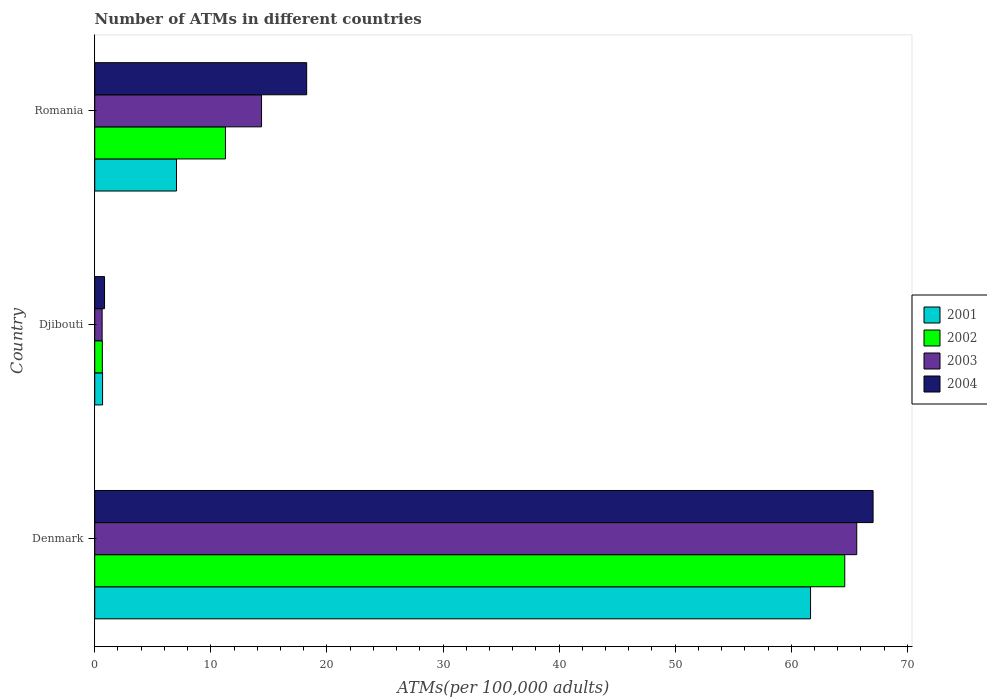How many groups of bars are there?
Keep it short and to the point. 3. Are the number of bars per tick equal to the number of legend labels?
Offer a terse response. Yes. Are the number of bars on each tick of the Y-axis equal?
Make the answer very short. Yes. How many bars are there on the 1st tick from the top?
Give a very brief answer. 4. How many bars are there on the 3rd tick from the bottom?
Give a very brief answer. 4. In how many cases, is the number of bars for a given country not equal to the number of legend labels?
Your answer should be very brief. 0. What is the number of ATMs in 2003 in Djibouti?
Keep it short and to the point. 0.64. Across all countries, what is the maximum number of ATMs in 2002?
Provide a succinct answer. 64.61. Across all countries, what is the minimum number of ATMs in 2001?
Keep it short and to the point. 0.68. In which country was the number of ATMs in 2002 minimum?
Your answer should be very brief. Djibouti. What is the total number of ATMs in 2001 in the graph?
Make the answer very short. 69.38. What is the difference between the number of ATMs in 2003 in Djibouti and that in Romania?
Your answer should be compact. -13.73. What is the difference between the number of ATMs in 2001 in Romania and the number of ATMs in 2002 in Djibouti?
Offer a terse response. 6.39. What is the average number of ATMs in 2002 per country?
Provide a short and direct response. 25.51. What is the difference between the number of ATMs in 2001 and number of ATMs in 2003 in Djibouti?
Offer a very short reply. 0.04. What is the ratio of the number of ATMs in 2003 in Denmark to that in Romania?
Provide a short and direct response. 4.57. What is the difference between the highest and the second highest number of ATMs in 2004?
Make the answer very short. 48.79. What is the difference between the highest and the lowest number of ATMs in 2004?
Your answer should be compact. 66.2. In how many countries, is the number of ATMs in 2003 greater than the average number of ATMs in 2003 taken over all countries?
Offer a very short reply. 1. Is the sum of the number of ATMs in 2003 in Denmark and Djibouti greater than the maximum number of ATMs in 2001 across all countries?
Offer a very short reply. Yes. Is it the case that in every country, the sum of the number of ATMs in 2002 and number of ATMs in 2001 is greater than the sum of number of ATMs in 2003 and number of ATMs in 2004?
Keep it short and to the point. No. What does the 4th bar from the bottom in Denmark represents?
Your answer should be compact. 2004. Are all the bars in the graph horizontal?
Your answer should be very brief. Yes. How many countries are there in the graph?
Provide a succinct answer. 3. What is the difference between two consecutive major ticks on the X-axis?
Ensure brevity in your answer.  10. Does the graph contain any zero values?
Provide a short and direct response. No. Where does the legend appear in the graph?
Offer a very short reply. Center right. What is the title of the graph?
Your answer should be compact. Number of ATMs in different countries. What is the label or title of the X-axis?
Keep it short and to the point. ATMs(per 100,0 adults). What is the label or title of the Y-axis?
Ensure brevity in your answer.  Country. What is the ATMs(per 100,000 adults) in 2001 in Denmark?
Ensure brevity in your answer.  61.66. What is the ATMs(per 100,000 adults) in 2002 in Denmark?
Give a very brief answer. 64.61. What is the ATMs(per 100,000 adults) of 2003 in Denmark?
Your answer should be very brief. 65.64. What is the ATMs(per 100,000 adults) of 2004 in Denmark?
Keep it short and to the point. 67.04. What is the ATMs(per 100,000 adults) of 2001 in Djibouti?
Give a very brief answer. 0.68. What is the ATMs(per 100,000 adults) in 2002 in Djibouti?
Offer a terse response. 0.66. What is the ATMs(per 100,000 adults) in 2003 in Djibouti?
Offer a very short reply. 0.64. What is the ATMs(per 100,000 adults) of 2004 in Djibouti?
Provide a short and direct response. 0.84. What is the ATMs(per 100,000 adults) of 2001 in Romania?
Provide a succinct answer. 7.04. What is the ATMs(per 100,000 adults) of 2002 in Romania?
Your answer should be compact. 11.26. What is the ATMs(per 100,000 adults) in 2003 in Romania?
Offer a terse response. 14.37. What is the ATMs(per 100,000 adults) of 2004 in Romania?
Your answer should be compact. 18.26. Across all countries, what is the maximum ATMs(per 100,000 adults) in 2001?
Offer a terse response. 61.66. Across all countries, what is the maximum ATMs(per 100,000 adults) in 2002?
Offer a terse response. 64.61. Across all countries, what is the maximum ATMs(per 100,000 adults) of 2003?
Offer a terse response. 65.64. Across all countries, what is the maximum ATMs(per 100,000 adults) in 2004?
Offer a very short reply. 67.04. Across all countries, what is the minimum ATMs(per 100,000 adults) in 2001?
Offer a terse response. 0.68. Across all countries, what is the minimum ATMs(per 100,000 adults) of 2002?
Your answer should be very brief. 0.66. Across all countries, what is the minimum ATMs(per 100,000 adults) of 2003?
Your response must be concise. 0.64. Across all countries, what is the minimum ATMs(per 100,000 adults) of 2004?
Offer a terse response. 0.84. What is the total ATMs(per 100,000 adults) of 2001 in the graph?
Your response must be concise. 69.38. What is the total ATMs(per 100,000 adults) in 2002 in the graph?
Your answer should be very brief. 76.52. What is the total ATMs(per 100,000 adults) in 2003 in the graph?
Your answer should be compact. 80.65. What is the total ATMs(per 100,000 adults) in 2004 in the graph?
Provide a short and direct response. 86.14. What is the difference between the ATMs(per 100,000 adults) of 2001 in Denmark and that in Djibouti?
Provide a succinct answer. 60.98. What is the difference between the ATMs(per 100,000 adults) of 2002 in Denmark and that in Djibouti?
Offer a very short reply. 63.95. What is the difference between the ATMs(per 100,000 adults) in 2003 in Denmark and that in Djibouti?
Provide a succinct answer. 65. What is the difference between the ATMs(per 100,000 adults) of 2004 in Denmark and that in Djibouti?
Make the answer very short. 66.2. What is the difference between the ATMs(per 100,000 adults) of 2001 in Denmark and that in Romania?
Give a very brief answer. 54.61. What is the difference between the ATMs(per 100,000 adults) of 2002 in Denmark and that in Romania?
Provide a succinct answer. 53.35. What is the difference between the ATMs(per 100,000 adults) in 2003 in Denmark and that in Romania?
Keep it short and to the point. 51.27. What is the difference between the ATMs(per 100,000 adults) of 2004 in Denmark and that in Romania?
Offer a terse response. 48.79. What is the difference between the ATMs(per 100,000 adults) of 2001 in Djibouti and that in Romania?
Provide a short and direct response. -6.37. What is the difference between the ATMs(per 100,000 adults) of 2002 in Djibouti and that in Romania?
Provide a succinct answer. -10.6. What is the difference between the ATMs(per 100,000 adults) in 2003 in Djibouti and that in Romania?
Provide a succinct answer. -13.73. What is the difference between the ATMs(per 100,000 adults) of 2004 in Djibouti and that in Romania?
Your answer should be very brief. -17.41. What is the difference between the ATMs(per 100,000 adults) in 2001 in Denmark and the ATMs(per 100,000 adults) in 2002 in Djibouti?
Your answer should be very brief. 61. What is the difference between the ATMs(per 100,000 adults) in 2001 in Denmark and the ATMs(per 100,000 adults) in 2003 in Djibouti?
Provide a succinct answer. 61.02. What is the difference between the ATMs(per 100,000 adults) of 2001 in Denmark and the ATMs(per 100,000 adults) of 2004 in Djibouti?
Provide a short and direct response. 60.81. What is the difference between the ATMs(per 100,000 adults) of 2002 in Denmark and the ATMs(per 100,000 adults) of 2003 in Djibouti?
Offer a terse response. 63.97. What is the difference between the ATMs(per 100,000 adults) of 2002 in Denmark and the ATMs(per 100,000 adults) of 2004 in Djibouti?
Your answer should be compact. 63.76. What is the difference between the ATMs(per 100,000 adults) in 2003 in Denmark and the ATMs(per 100,000 adults) in 2004 in Djibouti?
Ensure brevity in your answer.  64.79. What is the difference between the ATMs(per 100,000 adults) in 2001 in Denmark and the ATMs(per 100,000 adults) in 2002 in Romania?
Your response must be concise. 50.4. What is the difference between the ATMs(per 100,000 adults) in 2001 in Denmark and the ATMs(per 100,000 adults) in 2003 in Romania?
Ensure brevity in your answer.  47.29. What is the difference between the ATMs(per 100,000 adults) in 2001 in Denmark and the ATMs(per 100,000 adults) in 2004 in Romania?
Offer a very short reply. 43.4. What is the difference between the ATMs(per 100,000 adults) of 2002 in Denmark and the ATMs(per 100,000 adults) of 2003 in Romania?
Provide a succinct answer. 50.24. What is the difference between the ATMs(per 100,000 adults) of 2002 in Denmark and the ATMs(per 100,000 adults) of 2004 in Romania?
Give a very brief answer. 46.35. What is the difference between the ATMs(per 100,000 adults) in 2003 in Denmark and the ATMs(per 100,000 adults) in 2004 in Romania?
Provide a short and direct response. 47.38. What is the difference between the ATMs(per 100,000 adults) of 2001 in Djibouti and the ATMs(per 100,000 adults) of 2002 in Romania?
Offer a very short reply. -10.58. What is the difference between the ATMs(per 100,000 adults) of 2001 in Djibouti and the ATMs(per 100,000 adults) of 2003 in Romania?
Provide a short and direct response. -13.69. What is the difference between the ATMs(per 100,000 adults) of 2001 in Djibouti and the ATMs(per 100,000 adults) of 2004 in Romania?
Provide a short and direct response. -17.58. What is the difference between the ATMs(per 100,000 adults) of 2002 in Djibouti and the ATMs(per 100,000 adults) of 2003 in Romania?
Your answer should be compact. -13.71. What is the difference between the ATMs(per 100,000 adults) of 2002 in Djibouti and the ATMs(per 100,000 adults) of 2004 in Romania?
Your answer should be very brief. -17.6. What is the difference between the ATMs(per 100,000 adults) of 2003 in Djibouti and the ATMs(per 100,000 adults) of 2004 in Romania?
Give a very brief answer. -17.62. What is the average ATMs(per 100,000 adults) in 2001 per country?
Give a very brief answer. 23.13. What is the average ATMs(per 100,000 adults) of 2002 per country?
Your answer should be very brief. 25.51. What is the average ATMs(per 100,000 adults) of 2003 per country?
Your answer should be very brief. 26.88. What is the average ATMs(per 100,000 adults) of 2004 per country?
Your answer should be very brief. 28.71. What is the difference between the ATMs(per 100,000 adults) of 2001 and ATMs(per 100,000 adults) of 2002 in Denmark?
Make the answer very short. -2.95. What is the difference between the ATMs(per 100,000 adults) of 2001 and ATMs(per 100,000 adults) of 2003 in Denmark?
Offer a very short reply. -3.98. What is the difference between the ATMs(per 100,000 adults) in 2001 and ATMs(per 100,000 adults) in 2004 in Denmark?
Give a very brief answer. -5.39. What is the difference between the ATMs(per 100,000 adults) in 2002 and ATMs(per 100,000 adults) in 2003 in Denmark?
Provide a succinct answer. -1.03. What is the difference between the ATMs(per 100,000 adults) in 2002 and ATMs(per 100,000 adults) in 2004 in Denmark?
Ensure brevity in your answer.  -2.44. What is the difference between the ATMs(per 100,000 adults) in 2003 and ATMs(per 100,000 adults) in 2004 in Denmark?
Your answer should be very brief. -1.41. What is the difference between the ATMs(per 100,000 adults) in 2001 and ATMs(per 100,000 adults) in 2002 in Djibouti?
Ensure brevity in your answer.  0.02. What is the difference between the ATMs(per 100,000 adults) in 2001 and ATMs(per 100,000 adults) in 2003 in Djibouti?
Make the answer very short. 0.04. What is the difference between the ATMs(per 100,000 adults) in 2001 and ATMs(per 100,000 adults) in 2004 in Djibouti?
Your answer should be compact. -0.17. What is the difference between the ATMs(per 100,000 adults) in 2002 and ATMs(per 100,000 adults) in 2003 in Djibouti?
Offer a very short reply. 0.02. What is the difference between the ATMs(per 100,000 adults) in 2002 and ATMs(per 100,000 adults) in 2004 in Djibouti?
Ensure brevity in your answer.  -0.19. What is the difference between the ATMs(per 100,000 adults) of 2003 and ATMs(per 100,000 adults) of 2004 in Djibouti?
Make the answer very short. -0.21. What is the difference between the ATMs(per 100,000 adults) of 2001 and ATMs(per 100,000 adults) of 2002 in Romania?
Provide a short and direct response. -4.21. What is the difference between the ATMs(per 100,000 adults) of 2001 and ATMs(per 100,000 adults) of 2003 in Romania?
Your answer should be compact. -7.32. What is the difference between the ATMs(per 100,000 adults) in 2001 and ATMs(per 100,000 adults) in 2004 in Romania?
Your response must be concise. -11.21. What is the difference between the ATMs(per 100,000 adults) in 2002 and ATMs(per 100,000 adults) in 2003 in Romania?
Your answer should be very brief. -3.11. What is the difference between the ATMs(per 100,000 adults) in 2002 and ATMs(per 100,000 adults) in 2004 in Romania?
Keep it short and to the point. -7. What is the difference between the ATMs(per 100,000 adults) of 2003 and ATMs(per 100,000 adults) of 2004 in Romania?
Provide a succinct answer. -3.89. What is the ratio of the ATMs(per 100,000 adults) in 2001 in Denmark to that in Djibouti?
Ensure brevity in your answer.  91.18. What is the ratio of the ATMs(per 100,000 adults) of 2002 in Denmark to that in Djibouti?
Your response must be concise. 98.45. What is the ratio of the ATMs(per 100,000 adults) in 2003 in Denmark to that in Djibouti?
Offer a terse response. 102.88. What is the ratio of the ATMs(per 100,000 adults) of 2004 in Denmark to that in Djibouti?
Offer a terse response. 79.46. What is the ratio of the ATMs(per 100,000 adults) of 2001 in Denmark to that in Romania?
Make the answer very short. 8.75. What is the ratio of the ATMs(per 100,000 adults) of 2002 in Denmark to that in Romania?
Your response must be concise. 5.74. What is the ratio of the ATMs(per 100,000 adults) in 2003 in Denmark to that in Romania?
Offer a very short reply. 4.57. What is the ratio of the ATMs(per 100,000 adults) in 2004 in Denmark to that in Romania?
Your answer should be very brief. 3.67. What is the ratio of the ATMs(per 100,000 adults) of 2001 in Djibouti to that in Romania?
Offer a terse response. 0.1. What is the ratio of the ATMs(per 100,000 adults) in 2002 in Djibouti to that in Romania?
Provide a short and direct response. 0.06. What is the ratio of the ATMs(per 100,000 adults) of 2003 in Djibouti to that in Romania?
Ensure brevity in your answer.  0.04. What is the ratio of the ATMs(per 100,000 adults) of 2004 in Djibouti to that in Romania?
Your response must be concise. 0.05. What is the difference between the highest and the second highest ATMs(per 100,000 adults) in 2001?
Your response must be concise. 54.61. What is the difference between the highest and the second highest ATMs(per 100,000 adults) in 2002?
Your response must be concise. 53.35. What is the difference between the highest and the second highest ATMs(per 100,000 adults) in 2003?
Your response must be concise. 51.27. What is the difference between the highest and the second highest ATMs(per 100,000 adults) in 2004?
Your response must be concise. 48.79. What is the difference between the highest and the lowest ATMs(per 100,000 adults) of 2001?
Give a very brief answer. 60.98. What is the difference between the highest and the lowest ATMs(per 100,000 adults) in 2002?
Your answer should be compact. 63.95. What is the difference between the highest and the lowest ATMs(per 100,000 adults) in 2003?
Your answer should be very brief. 65. What is the difference between the highest and the lowest ATMs(per 100,000 adults) of 2004?
Make the answer very short. 66.2. 